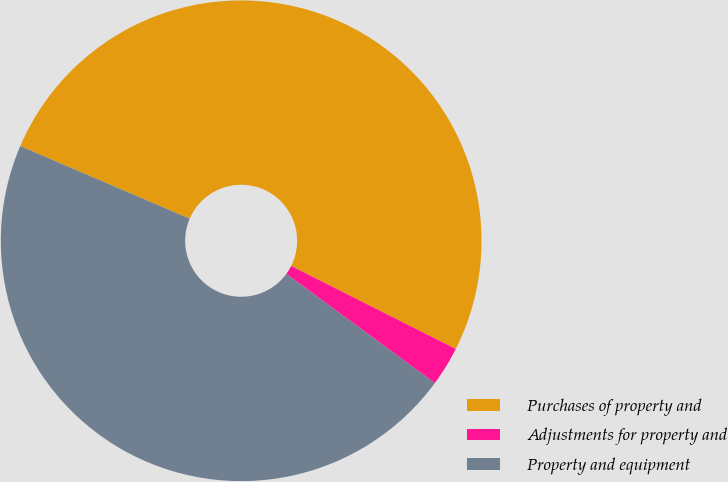<chart> <loc_0><loc_0><loc_500><loc_500><pie_chart><fcel>Purchases of property and<fcel>Adjustments for property and<fcel>Property and equipment<nl><fcel>50.99%<fcel>2.66%<fcel>46.35%<nl></chart> 